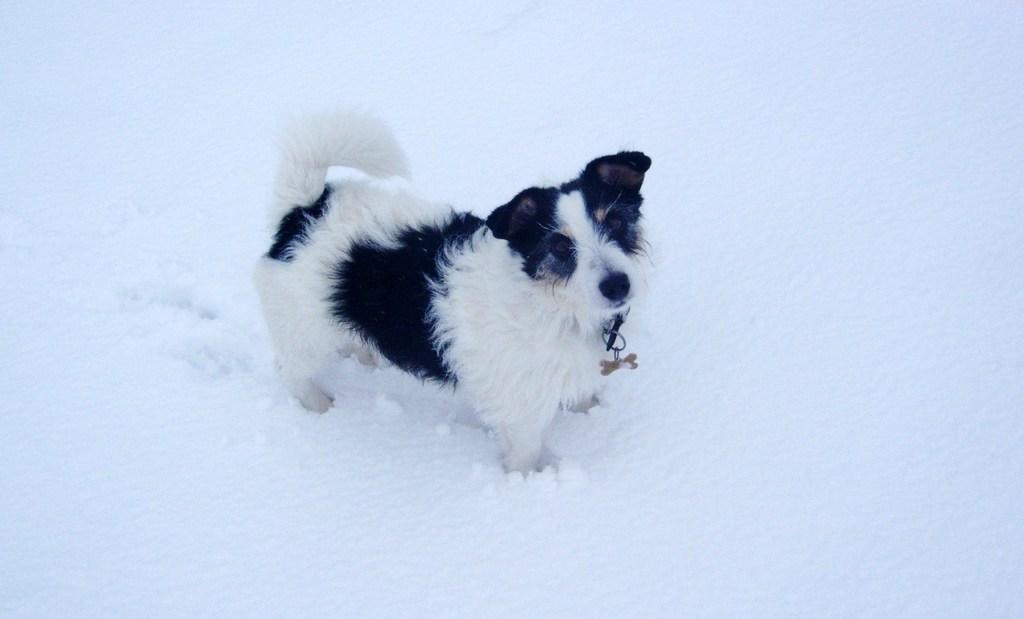Describe this image in one or two sentences. In this image there is a dog in the center and on the ground there is snow. 